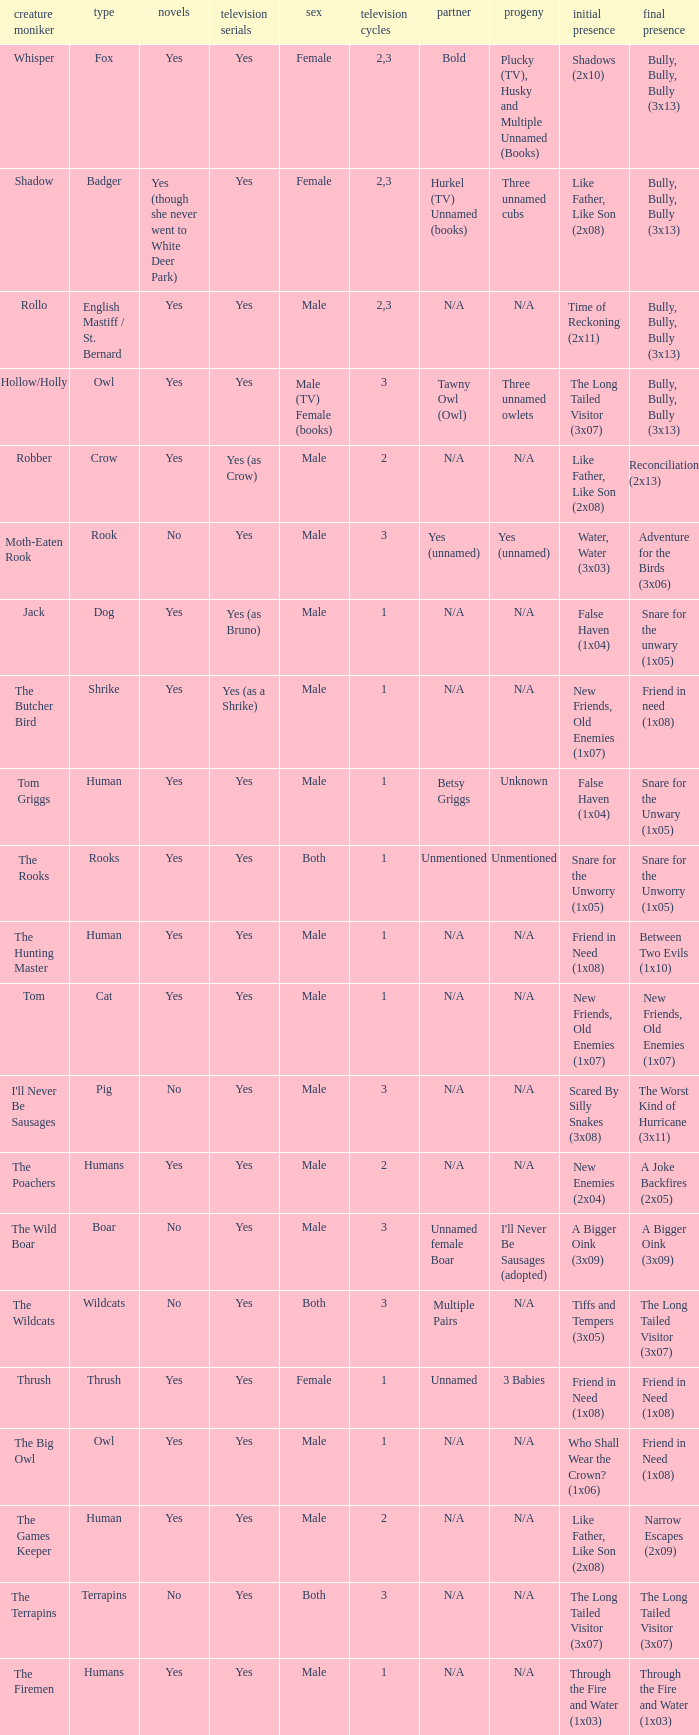What animal was yes for tv series and was a terrapins? The Terrapins. 